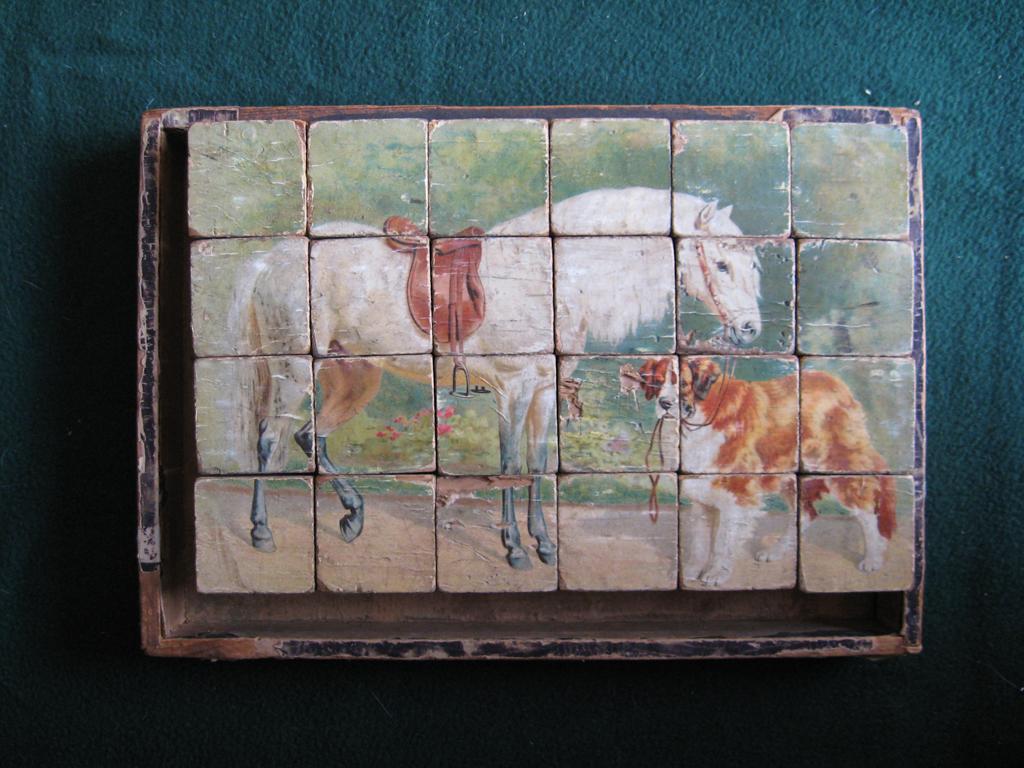Describe this image in one or two sentences. In this image we can see a painting of a dog and horse on some blocks placed on a frame kept on the surface. 